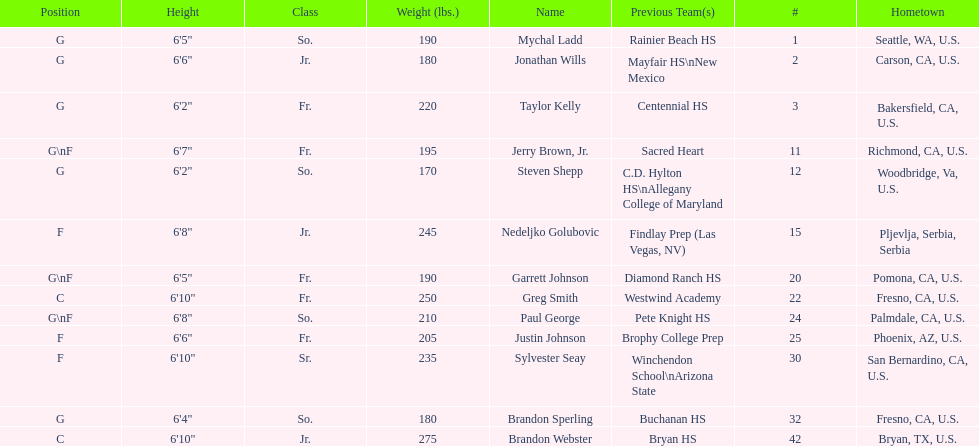How many players possess a weight of over 200 pounds? 7. 